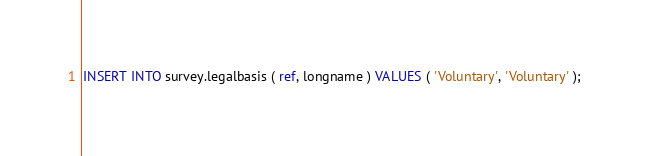<code> <loc_0><loc_0><loc_500><loc_500><_SQL_>
INSERT INTO survey.legalbasis ( ref, longname ) VALUES ( 'Voluntary', 'Voluntary' );</code> 